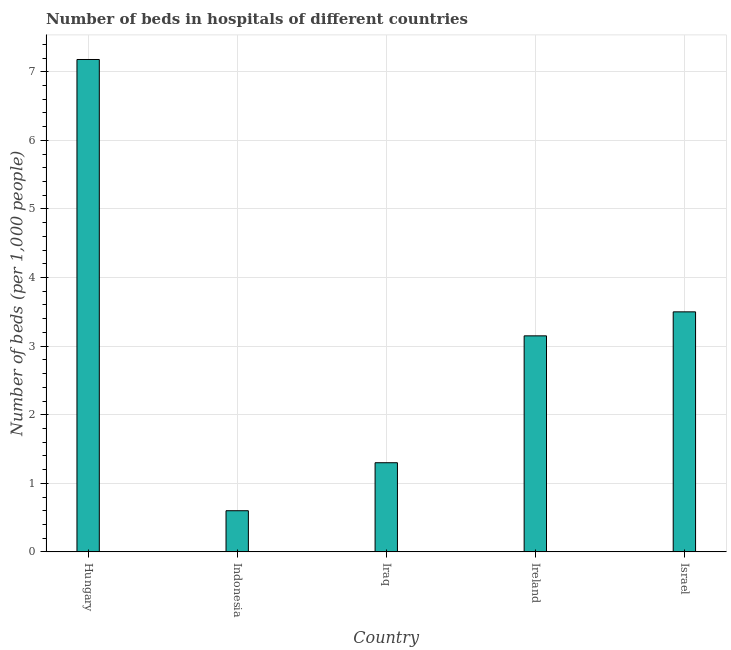What is the title of the graph?
Offer a terse response. Number of beds in hospitals of different countries. What is the label or title of the Y-axis?
Your response must be concise. Number of beds (per 1,0 people). What is the number of hospital beds in Iraq?
Ensure brevity in your answer.  1.3. Across all countries, what is the maximum number of hospital beds?
Offer a very short reply. 7.18. In which country was the number of hospital beds maximum?
Ensure brevity in your answer.  Hungary. What is the sum of the number of hospital beds?
Provide a succinct answer. 15.73. What is the average number of hospital beds per country?
Keep it short and to the point. 3.15. What is the median number of hospital beds?
Keep it short and to the point. 3.15. In how many countries, is the number of hospital beds greater than 5 %?
Ensure brevity in your answer.  1. What is the ratio of the number of hospital beds in Indonesia to that in Iraq?
Your response must be concise. 0.46. Is the difference between the number of hospital beds in Iraq and Israel greater than the difference between any two countries?
Offer a very short reply. No. What is the difference between the highest and the second highest number of hospital beds?
Ensure brevity in your answer.  3.68. Is the sum of the number of hospital beds in Indonesia and Iraq greater than the maximum number of hospital beds across all countries?
Your answer should be compact. No. What is the difference between the highest and the lowest number of hospital beds?
Your answer should be compact. 6.58. How many bars are there?
Give a very brief answer. 5. Are all the bars in the graph horizontal?
Provide a short and direct response. No. How many countries are there in the graph?
Ensure brevity in your answer.  5. What is the difference between two consecutive major ticks on the Y-axis?
Your response must be concise. 1. What is the Number of beds (per 1,000 people) of Hungary?
Your answer should be very brief. 7.18. What is the Number of beds (per 1,000 people) of Ireland?
Provide a succinct answer. 3.15. What is the Number of beds (per 1,000 people) of Israel?
Keep it short and to the point. 3.5. What is the difference between the Number of beds (per 1,000 people) in Hungary and Indonesia?
Keep it short and to the point. 6.58. What is the difference between the Number of beds (per 1,000 people) in Hungary and Iraq?
Offer a terse response. 5.88. What is the difference between the Number of beds (per 1,000 people) in Hungary and Ireland?
Make the answer very short. 4.03. What is the difference between the Number of beds (per 1,000 people) in Hungary and Israel?
Your response must be concise. 3.68. What is the difference between the Number of beds (per 1,000 people) in Indonesia and Iraq?
Your response must be concise. -0.7. What is the difference between the Number of beds (per 1,000 people) in Indonesia and Ireland?
Offer a terse response. -2.55. What is the difference between the Number of beds (per 1,000 people) in Iraq and Ireland?
Make the answer very short. -1.85. What is the difference between the Number of beds (per 1,000 people) in Iraq and Israel?
Keep it short and to the point. -2.2. What is the difference between the Number of beds (per 1,000 people) in Ireland and Israel?
Make the answer very short. -0.35. What is the ratio of the Number of beds (per 1,000 people) in Hungary to that in Indonesia?
Give a very brief answer. 11.97. What is the ratio of the Number of beds (per 1,000 people) in Hungary to that in Iraq?
Keep it short and to the point. 5.52. What is the ratio of the Number of beds (per 1,000 people) in Hungary to that in Ireland?
Your answer should be very brief. 2.28. What is the ratio of the Number of beds (per 1,000 people) in Hungary to that in Israel?
Offer a terse response. 2.05. What is the ratio of the Number of beds (per 1,000 people) in Indonesia to that in Iraq?
Keep it short and to the point. 0.46. What is the ratio of the Number of beds (per 1,000 people) in Indonesia to that in Ireland?
Ensure brevity in your answer.  0.19. What is the ratio of the Number of beds (per 1,000 people) in Indonesia to that in Israel?
Your response must be concise. 0.17. What is the ratio of the Number of beds (per 1,000 people) in Iraq to that in Ireland?
Ensure brevity in your answer.  0.41. What is the ratio of the Number of beds (per 1,000 people) in Iraq to that in Israel?
Your answer should be very brief. 0.37. What is the ratio of the Number of beds (per 1,000 people) in Ireland to that in Israel?
Provide a succinct answer. 0.9. 